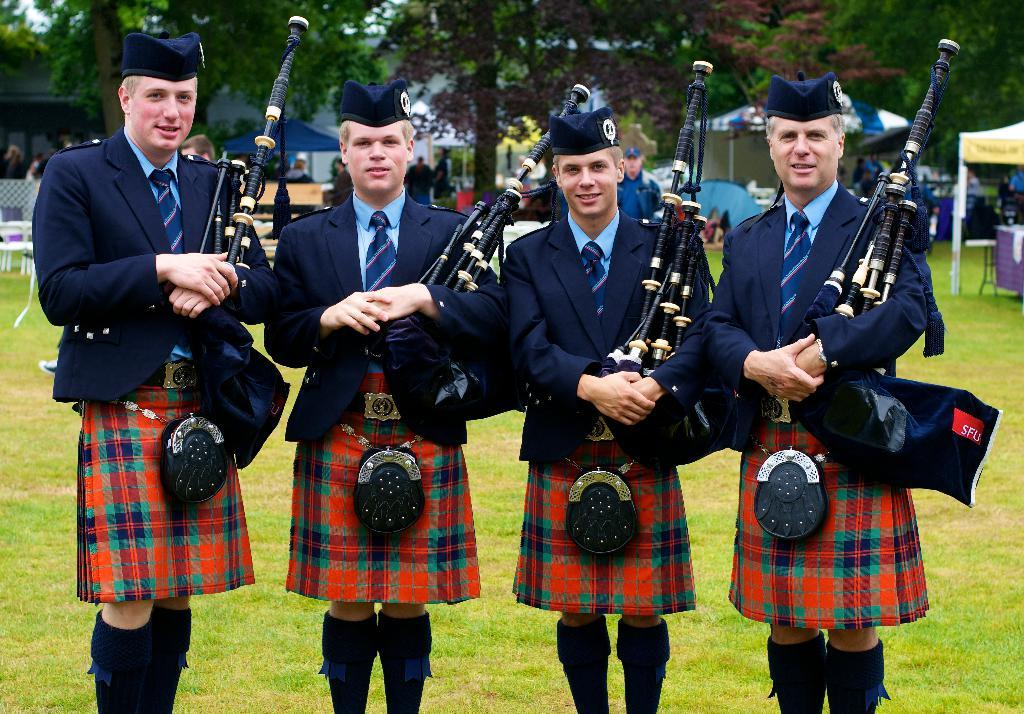How many people are in the image? There are four persons in the image. What are the persons holding in the image? The persons are standing and holding bagpipes. What can be seen in the background of the image? There are stalls and trees in the background of the image. Are there any other people visible in the image? Yes, there is a group of people in the background of the image. What type of transport can be seen in the image? There is no transport visible in the image. 